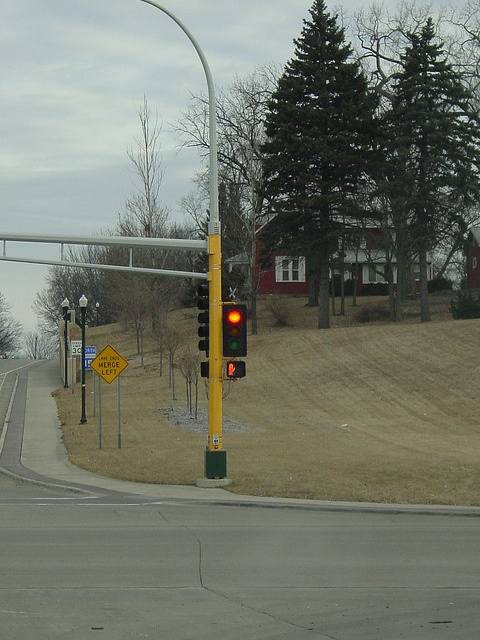Describe the objects in this image and their specific colors. I can see traffic light in lightgray, black, maroon, orange, and red tones, traffic light in lightgray, black, gray, darkgreen, and olive tones, traffic light in lightgray, black, maroon, red, and salmon tones, and traffic light in lightgray, black, and gray tones in this image. 